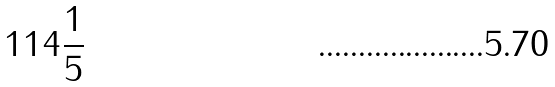Convert formula to latex. <formula><loc_0><loc_0><loc_500><loc_500>1 1 4 \frac { 1 } { 5 }</formula> 